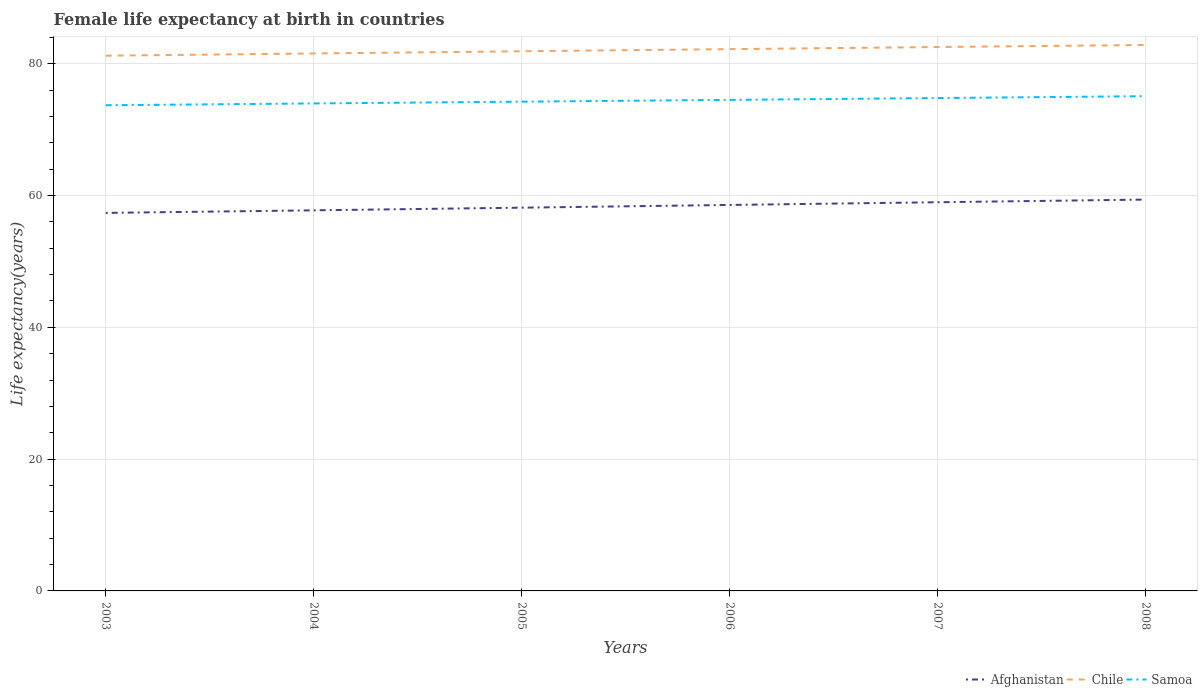Does the line corresponding to Afghanistan intersect with the line corresponding to Chile?
Your response must be concise. No. Is the number of lines equal to the number of legend labels?
Provide a succinct answer. Yes. Across all years, what is the maximum female life expectancy at birth in Chile?
Provide a succinct answer. 81.21. In which year was the female life expectancy at birth in Chile maximum?
Ensure brevity in your answer.  2003. What is the total female life expectancy at birth in Samoa in the graph?
Your response must be concise. -1.1. What is the difference between the highest and the second highest female life expectancy at birth in Samoa?
Ensure brevity in your answer.  1.38. How many lines are there?
Give a very brief answer. 3. What is the difference between two consecutive major ticks on the Y-axis?
Provide a succinct answer. 20. Are the values on the major ticks of Y-axis written in scientific E-notation?
Make the answer very short. No. Where does the legend appear in the graph?
Provide a short and direct response. Bottom right. What is the title of the graph?
Keep it short and to the point. Female life expectancy at birth in countries. What is the label or title of the Y-axis?
Your answer should be compact. Life expectancy(years). What is the Life expectancy(years) of Afghanistan in 2003?
Offer a very short reply. 57.36. What is the Life expectancy(years) of Chile in 2003?
Provide a short and direct response. 81.21. What is the Life expectancy(years) in Samoa in 2003?
Offer a very short reply. 73.69. What is the Life expectancy(years) of Afghanistan in 2004?
Keep it short and to the point. 57.75. What is the Life expectancy(years) of Chile in 2004?
Provide a succinct answer. 81.55. What is the Life expectancy(years) of Samoa in 2004?
Offer a terse response. 73.97. What is the Life expectancy(years) in Afghanistan in 2005?
Your answer should be very brief. 58.15. What is the Life expectancy(years) in Chile in 2005?
Provide a succinct answer. 81.88. What is the Life expectancy(years) in Samoa in 2005?
Give a very brief answer. 74.23. What is the Life expectancy(years) of Afghanistan in 2006?
Your answer should be very brief. 58.56. What is the Life expectancy(years) in Chile in 2006?
Your answer should be very brief. 82.21. What is the Life expectancy(years) of Samoa in 2006?
Your answer should be very brief. 74.51. What is the Life expectancy(years) of Afghanistan in 2007?
Offer a very short reply. 58.98. What is the Life expectancy(years) in Chile in 2007?
Offer a very short reply. 82.53. What is the Life expectancy(years) of Samoa in 2007?
Give a very brief answer. 74.78. What is the Life expectancy(years) in Afghanistan in 2008?
Your answer should be compact. 59.38. What is the Life expectancy(years) in Chile in 2008?
Your response must be concise. 82.84. What is the Life expectancy(years) in Samoa in 2008?
Your answer should be compact. 75.07. Across all years, what is the maximum Life expectancy(years) of Afghanistan?
Provide a succinct answer. 59.38. Across all years, what is the maximum Life expectancy(years) in Chile?
Provide a short and direct response. 82.84. Across all years, what is the maximum Life expectancy(years) in Samoa?
Provide a succinct answer. 75.07. Across all years, what is the minimum Life expectancy(years) of Afghanistan?
Provide a short and direct response. 57.36. Across all years, what is the minimum Life expectancy(years) in Chile?
Offer a terse response. 81.21. Across all years, what is the minimum Life expectancy(years) in Samoa?
Make the answer very short. 73.69. What is the total Life expectancy(years) in Afghanistan in the graph?
Provide a short and direct response. 350.17. What is the total Life expectancy(years) of Chile in the graph?
Offer a terse response. 492.21. What is the total Life expectancy(years) in Samoa in the graph?
Offer a terse response. 446.25. What is the difference between the Life expectancy(years) of Afghanistan in 2003 and that in 2004?
Give a very brief answer. -0.39. What is the difference between the Life expectancy(years) in Chile in 2003 and that in 2004?
Make the answer very short. -0.34. What is the difference between the Life expectancy(years) of Samoa in 2003 and that in 2004?
Ensure brevity in your answer.  -0.27. What is the difference between the Life expectancy(years) in Afghanistan in 2003 and that in 2005?
Keep it short and to the point. -0.79. What is the difference between the Life expectancy(years) of Chile in 2003 and that in 2005?
Offer a very short reply. -0.67. What is the difference between the Life expectancy(years) of Samoa in 2003 and that in 2005?
Make the answer very short. -0.54. What is the difference between the Life expectancy(years) of Afghanistan in 2003 and that in 2006?
Make the answer very short. -1.21. What is the difference between the Life expectancy(years) of Chile in 2003 and that in 2006?
Your answer should be very brief. -1. What is the difference between the Life expectancy(years) in Samoa in 2003 and that in 2006?
Give a very brief answer. -0.81. What is the difference between the Life expectancy(years) in Afghanistan in 2003 and that in 2007?
Make the answer very short. -1.62. What is the difference between the Life expectancy(years) of Chile in 2003 and that in 2007?
Make the answer very short. -1.31. What is the difference between the Life expectancy(years) in Samoa in 2003 and that in 2007?
Your answer should be compact. -1.09. What is the difference between the Life expectancy(years) of Afghanistan in 2003 and that in 2008?
Give a very brief answer. -2.02. What is the difference between the Life expectancy(years) in Chile in 2003 and that in 2008?
Your response must be concise. -1.63. What is the difference between the Life expectancy(years) of Samoa in 2003 and that in 2008?
Make the answer very short. -1.38. What is the difference between the Life expectancy(years) of Afghanistan in 2004 and that in 2005?
Provide a short and direct response. -0.4. What is the difference between the Life expectancy(years) of Chile in 2004 and that in 2005?
Your answer should be very brief. -0.33. What is the difference between the Life expectancy(years) in Samoa in 2004 and that in 2005?
Offer a very short reply. -0.27. What is the difference between the Life expectancy(years) in Afghanistan in 2004 and that in 2006?
Ensure brevity in your answer.  -0.82. What is the difference between the Life expectancy(years) of Chile in 2004 and that in 2006?
Make the answer very short. -0.66. What is the difference between the Life expectancy(years) of Samoa in 2004 and that in 2006?
Your answer should be very brief. -0.54. What is the difference between the Life expectancy(years) of Afghanistan in 2004 and that in 2007?
Ensure brevity in your answer.  -1.23. What is the difference between the Life expectancy(years) in Chile in 2004 and that in 2007?
Make the answer very short. -0.98. What is the difference between the Life expectancy(years) of Samoa in 2004 and that in 2007?
Your answer should be very brief. -0.82. What is the difference between the Life expectancy(years) in Afghanistan in 2004 and that in 2008?
Your answer should be compact. -1.63. What is the difference between the Life expectancy(years) of Chile in 2004 and that in 2008?
Your response must be concise. -1.29. What is the difference between the Life expectancy(years) of Samoa in 2004 and that in 2008?
Offer a very short reply. -1.1. What is the difference between the Life expectancy(years) in Afghanistan in 2005 and that in 2006?
Give a very brief answer. -0.41. What is the difference between the Life expectancy(years) of Chile in 2005 and that in 2006?
Your response must be concise. -0.33. What is the difference between the Life expectancy(years) in Samoa in 2005 and that in 2006?
Make the answer very short. -0.27. What is the difference between the Life expectancy(years) in Afghanistan in 2005 and that in 2007?
Provide a succinct answer. -0.82. What is the difference between the Life expectancy(years) in Chile in 2005 and that in 2007?
Make the answer very short. -0.64. What is the difference between the Life expectancy(years) in Samoa in 2005 and that in 2007?
Offer a very short reply. -0.55. What is the difference between the Life expectancy(years) of Afghanistan in 2005 and that in 2008?
Your answer should be compact. -1.23. What is the difference between the Life expectancy(years) in Chile in 2005 and that in 2008?
Provide a succinct answer. -0.96. What is the difference between the Life expectancy(years) in Samoa in 2005 and that in 2008?
Give a very brief answer. -0.83. What is the difference between the Life expectancy(years) in Afghanistan in 2006 and that in 2007?
Provide a short and direct response. -0.41. What is the difference between the Life expectancy(years) of Chile in 2006 and that in 2007?
Make the answer very short. -0.32. What is the difference between the Life expectancy(years) in Samoa in 2006 and that in 2007?
Offer a very short reply. -0.28. What is the difference between the Life expectancy(years) in Afghanistan in 2006 and that in 2008?
Your answer should be very brief. -0.81. What is the difference between the Life expectancy(years) in Chile in 2006 and that in 2008?
Provide a succinct answer. -0.63. What is the difference between the Life expectancy(years) in Samoa in 2006 and that in 2008?
Your answer should be compact. -0.56. What is the difference between the Life expectancy(years) in Afghanistan in 2007 and that in 2008?
Provide a short and direct response. -0.4. What is the difference between the Life expectancy(years) in Chile in 2007 and that in 2008?
Give a very brief answer. -0.31. What is the difference between the Life expectancy(years) in Samoa in 2007 and that in 2008?
Offer a terse response. -0.28. What is the difference between the Life expectancy(years) of Afghanistan in 2003 and the Life expectancy(years) of Chile in 2004?
Provide a short and direct response. -24.19. What is the difference between the Life expectancy(years) of Afghanistan in 2003 and the Life expectancy(years) of Samoa in 2004?
Your answer should be compact. -16.61. What is the difference between the Life expectancy(years) of Chile in 2003 and the Life expectancy(years) of Samoa in 2004?
Offer a terse response. 7.25. What is the difference between the Life expectancy(years) of Afghanistan in 2003 and the Life expectancy(years) of Chile in 2005?
Provide a short and direct response. -24.52. What is the difference between the Life expectancy(years) of Afghanistan in 2003 and the Life expectancy(years) of Samoa in 2005?
Offer a terse response. -16.88. What is the difference between the Life expectancy(years) in Chile in 2003 and the Life expectancy(years) in Samoa in 2005?
Provide a succinct answer. 6.98. What is the difference between the Life expectancy(years) of Afghanistan in 2003 and the Life expectancy(years) of Chile in 2006?
Your answer should be compact. -24.85. What is the difference between the Life expectancy(years) of Afghanistan in 2003 and the Life expectancy(years) of Samoa in 2006?
Give a very brief answer. -17.15. What is the difference between the Life expectancy(years) of Chile in 2003 and the Life expectancy(years) of Samoa in 2006?
Your response must be concise. 6.7. What is the difference between the Life expectancy(years) of Afghanistan in 2003 and the Life expectancy(years) of Chile in 2007?
Give a very brief answer. -25.17. What is the difference between the Life expectancy(years) in Afghanistan in 2003 and the Life expectancy(years) in Samoa in 2007?
Keep it short and to the point. -17.43. What is the difference between the Life expectancy(years) of Chile in 2003 and the Life expectancy(years) of Samoa in 2007?
Give a very brief answer. 6.43. What is the difference between the Life expectancy(years) in Afghanistan in 2003 and the Life expectancy(years) in Chile in 2008?
Keep it short and to the point. -25.48. What is the difference between the Life expectancy(years) of Afghanistan in 2003 and the Life expectancy(years) of Samoa in 2008?
Keep it short and to the point. -17.71. What is the difference between the Life expectancy(years) of Chile in 2003 and the Life expectancy(years) of Samoa in 2008?
Make the answer very short. 6.14. What is the difference between the Life expectancy(years) in Afghanistan in 2004 and the Life expectancy(years) in Chile in 2005?
Keep it short and to the point. -24.13. What is the difference between the Life expectancy(years) of Afghanistan in 2004 and the Life expectancy(years) of Samoa in 2005?
Give a very brief answer. -16.49. What is the difference between the Life expectancy(years) in Chile in 2004 and the Life expectancy(years) in Samoa in 2005?
Keep it short and to the point. 7.32. What is the difference between the Life expectancy(years) of Afghanistan in 2004 and the Life expectancy(years) of Chile in 2006?
Your answer should be compact. -24.46. What is the difference between the Life expectancy(years) of Afghanistan in 2004 and the Life expectancy(years) of Samoa in 2006?
Ensure brevity in your answer.  -16.76. What is the difference between the Life expectancy(years) in Chile in 2004 and the Life expectancy(years) in Samoa in 2006?
Provide a succinct answer. 7.04. What is the difference between the Life expectancy(years) of Afghanistan in 2004 and the Life expectancy(years) of Chile in 2007?
Provide a succinct answer. -24.78. What is the difference between the Life expectancy(years) in Afghanistan in 2004 and the Life expectancy(years) in Samoa in 2007?
Offer a terse response. -17.04. What is the difference between the Life expectancy(years) in Chile in 2004 and the Life expectancy(years) in Samoa in 2007?
Keep it short and to the point. 6.77. What is the difference between the Life expectancy(years) of Afghanistan in 2004 and the Life expectancy(years) of Chile in 2008?
Your answer should be very brief. -25.09. What is the difference between the Life expectancy(years) in Afghanistan in 2004 and the Life expectancy(years) in Samoa in 2008?
Your answer should be very brief. -17.32. What is the difference between the Life expectancy(years) in Chile in 2004 and the Life expectancy(years) in Samoa in 2008?
Ensure brevity in your answer.  6.48. What is the difference between the Life expectancy(years) in Afghanistan in 2005 and the Life expectancy(years) in Chile in 2006?
Your answer should be compact. -24.05. What is the difference between the Life expectancy(years) of Afghanistan in 2005 and the Life expectancy(years) of Samoa in 2006?
Offer a terse response. -16.36. What is the difference between the Life expectancy(years) in Chile in 2005 and the Life expectancy(years) in Samoa in 2006?
Give a very brief answer. 7.38. What is the difference between the Life expectancy(years) of Afghanistan in 2005 and the Life expectancy(years) of Chile in 2007?
Give a very brief answer. -24.37. What is the difference between the Life expectancy(years) in Afghanistan in 2005 and the Life expectancy(years) in Samoa in 2007?
Your response must be concise. -16.63. What is the difference between the Life expectancy(years) in Chile in 2005 and the Life expectancy(years) in Samoa in 2007?
Offer a very short reply. 7.1. What is the difference between the Life expectancy(years) in Afghanistan in 2005 and the Life expectancy(years) in Chile in 2008?
Ensure brevity in your answer.  -24.69. What is the difference between the Life expectancy(years) of Afghanistan in 2005 and the Life expectancy(years) of Samoa in 2008?
Make the answer very short. -16.91. What is the difference between the Life expectancy(years) in Chile in 2005 and the Life expectancy(years) in Samoa in 2008?
Ensure brevity in your answer.  6.82. What is the difference between the Life expectancy(years) in Afghanistan in 2006 and the Life expectancy(years) in Chile in 2007?
Provide a succinct answer. -23.96. What is the difference between the Life expectancy(years) in Afghanistan in 2006 and the Life expectancy(years) in Samoa in 2007?
Make the answer very short. -16.22. What is the difference between the Life expectancy(years) of Chile in 2006 and the Life expectancy(years) of Samoa in 2007?
Give a very brief answer. 7.42. What is the difference between the Life expectancy(years) in Afghanistan in 2006 and the Life expectancy(years) in Chile in 2008?
Ensure brevity in your answer.  -24.27. What is the difference between the Life expectancy(years) in Afghanistan in 2006 and the Life expectancy(years) in Samoa in 2008?
Your answer should be very brief. -16.5. What is the difference between the Life expectancy(years) in Chile in 2006 and the Life expectancy(years) in Samoa in 2008?
Your answer should be very brief. 7.14. What is the difference between the Life expectancy(years) of Afghanistan in 2007 and the Life expectancy(years) of Chile in 2008?
Offer a terse response. -23.86. What is the difference between the Life expectancy(years) in Afghanistan in 2007 and the Life expectancy(years) in Samoa in 2008?
Ensure brevity in your answer.  -16.09. What is the difference between the Life expectancy(years) of Chile in 2007 and the Life expectancy(years) of Samoa in 2008?
Your response must be concise. 7.46. What is the average Life expectancy(years) of Afghanistan per year?
Offer a very short reply. 58.36. What is the average Life expectancy(years) in Chile per year?
Ensure brevity in your answer.  82.03. What is the average Life expectancy(years) in Samoa per year?
Your answer should be compact. 74.37. In the year 2003, what is the difference between the Life expectancy(years) in Afghanistan and Life expectancy(years) in Chile?
Offer a terse response. -23.85. In the year 2003, what is the difference between the Life expectancy(years) in Afghanistan and Life expectancy(years) in Samoa?
Provide a succinct answer. -16.33. In the year 2003, what is the difference between the Life expectancy(years) of Chile and Life expectancy(years) of Samoa?
Ensure brevity in your answer.  7.52. In the year 2004, what is the difference between the Life expectancy(years) of Afghanistan and Life expectancy(years) of Chile?
Give a very brief answer. -23.8. In the year 2004, what is the difference between the Life expectancy(years) in Afghanistan and Life expectancy(years) in Samoa?
Provide a succinct answer. -16.22. In the year 2004, what is the difference between the Life expectancy(years) of Chile and Life expectancy(years) of Samoa?
Your response must be concise. 7.58. In the year 2005, what is the difference between the Life expectancy(years) in Afghanistan and Life expectancy(years) in Chile?
Offer a very short reply. -23.73. In the year 2005, what is the difference between the Life expectancy(years) of Afghanistan and Life expectancy(years) of Samoa?
Provide a succinct answer. -16.08. In the year 2005, what is the difference between the Life expectancy(years) of Chile and Life expectancy(years) of Samoa?
Your answer should be very brief. 7.65. In the year 2006, what is the difference between the Life expectancy(years) in Afghanistan and Life expectancy(years) in Chile?
Provide a short and direct response. -23.64. In the year 2006, what is the difference between the Life expectancy(years) of Afghanistan and Life expectancy(years) of Samoa?
Your answer should be compact. -15.94. In the year 2007, what is the difference between the Life expectancy(years) in Afghanistan and Life expectancy(years) in Chile?
Your response must be concise. -23.55. In the year 2007, what is the difference between the Life expectancy(years) in Afghanistan and Life expectancy(years) in Samoa?
Your answer should be compact. -15.81. In the year 2007, what is the difference between the Life expectancy(years) in Chile and Life expectancy(years) in Samoa?
Provide a succinct answer. 7.74. In the year 2008, what is the difference between the Life expectancy(years) in Afghanistan and Life expectancy(years) in Chile?
Provide a short and direct response. -23.46. In the year 2008, what is the difference between the Life expectancy(years) in Afghanistan and Life expectancy(years) in Samoa?
Provide a short and direct response. -15.69. In the year 2008, what is the difference between the Life expectancy(years) of Chile and Life expectancy(years) of Samoa?
Provide a succinct answer. 7.77. What is the ratio of the Life expectancy(years) in Afghanistan in 2003 to that in 2004?
Provide a short and direct response. 0.99. What is the ratio of the Life expectancy(years) in Afghanistan in 2003 to that in 2005?
Your answer should be compact. 0.99. What is the ratio of the Life expectancy(years) of Chile in 2003 to that in 2005?
Provide a short and direct response. 0.99. What is the ratio of the Life expectancy(years) of Afghanistan in 2003 to that in 2006?
Offer a very short reply. 0.98. What is the ratio of the Life expectancy(years) in Chile in 2003 to that in 2006?
Your response must be concise. 0.99. What is the ratio of the Life expectancy(years) of Afghanistan in 2003 to that in 2007?
Offer a terse response. 0.97. What is the ratio of the Life expectancy(years) in Chile in 2003 to that in 2007?
Your answer should be compact. 0.98. What is the ratio of the Life expectancy(years) in Samoa in 2003 to that in 2007?
Ensure brevity in your answer.  0.99. What is the ratio of the Life expectancy(years) in Afghanistan in 2003 to that in 2008?
Keep it short and to the point. 0.97. What is the ratio of the Life expectancy(years) of Chile in 2003 to that in 2008?
Your answer should be very brief. 0.98. What is the ratio of the Life expectancy(years) in Samoa in 2003 to that in 2008?
Give a very brief answer. 0.98. What is the ratio of the Life expectancy(years) of Afghanistan in 2004 to that in 2005?
Your answer should be very brief. 0.99. What is the ratio of the Life expectancy(years) in Chile in 2004 to that in 2005?
Provide a succinct answer. 1. What is the ratio of the Life expectancy(years) of Samoa in 2004 to that in 2005?
Ensure brevity in your answer.  1. What is the ratio of the Life expectancy(years) of Chile in 2004 to that in 2006?
Make the answer very short. 0.99. What is the ratio of the Life expectancy(years) of Afghanistan in 2004 to that in 2007?
Your response must be concise. 0.98. What is the ratio of the Life expectancy(years) of Chile in 2004 to that in 2007?
Offer a very short reply. 0.99. What is the ratio of the Life expectancy(years) of Samoa in 2004 to that in 2007?
Your response must be concise. 0.99. What is the ratio of the Life expectancy(years) of Afghanistan in 2004 to that in 2008?
Offer a very short reply. 0.97. What is the ratio of the Life expectancy(years) of Chile in 2004 to that in 2008?
Provide a short and direct response. 0.98. What is the ratio of the Life expectancy(years) of Samoa in 2004 to that in 2008?
Provide a succinct answer. 0.99. What is the ratio of the Life expectancy(years) of Chile in 2005 to that in 2006?
Provide a succinct answer. 1. What is the ratio of the Life expectancy(years) of Samoa in 2005 to that in 2006?
Your answer should be very brief. 1. What is the ratio of the Life expectancy(years) of Chile in 2005 to that in 2007?
Offer a terse response. 0.99. What is the ratio of the Life expectancy(years) of Samoa in 2005 to that in 2007?
Your answer should be compact. 0.99. What is the ratio of the Life expectancy(years) in Afghanistan in 2005 to that in 2008?
Your answer should be very brief. 0.98. What is the ratio of the Life expectancy(years) of Chile in 2005 to that in 2008?
Ensure brevity in your answer.  0.99. What is the ratio of the Life expectancy(years) in Samoa in 2005 to that in 2008?
Offer a terse response. 0.99. What is the ratio of the Life expectancy(years) in Afghanistan in 2006 to that in 2008?
Keep it short and to the point. 0.99. What is the ratio of the Life expectancy(years) in Chile in 2006 to that in 2008?
Keep it short and to the point. 0.99. What is the ratio of the Life expectancy(years) in Chile in 2007 to that in 2008?
Offer a terse response. 1. What is the ratio of the Life expectancy(years) in Samoa in 2007 to that in 2008?
Make the answer very short. 1. What is the difference between the highest and the second highest Life expectancy(years) in Afghanistan?
Your answer should be very brief. 0.4. What is the difference between the highest and the second highest Life expectancy(years) in Chile?
Offer a terse response. 0.31. What is the difference between the highest and the second highest Life expectancy(years) in Samoa?
Keep it short and to the point. 0.28. What is the difference between the highest and the lowest Life expectancy(years) of Afghanistan?
Ensure brevity in your answer.  2.02. What is the difference between the highest and the lowest Life expectancy(years) in Chile?
Your response must be concise. 1.63. What is the difference between the highest and the lowest Life expectancy(years) of Samoa?
Provide a succinct answer. 1.38. 